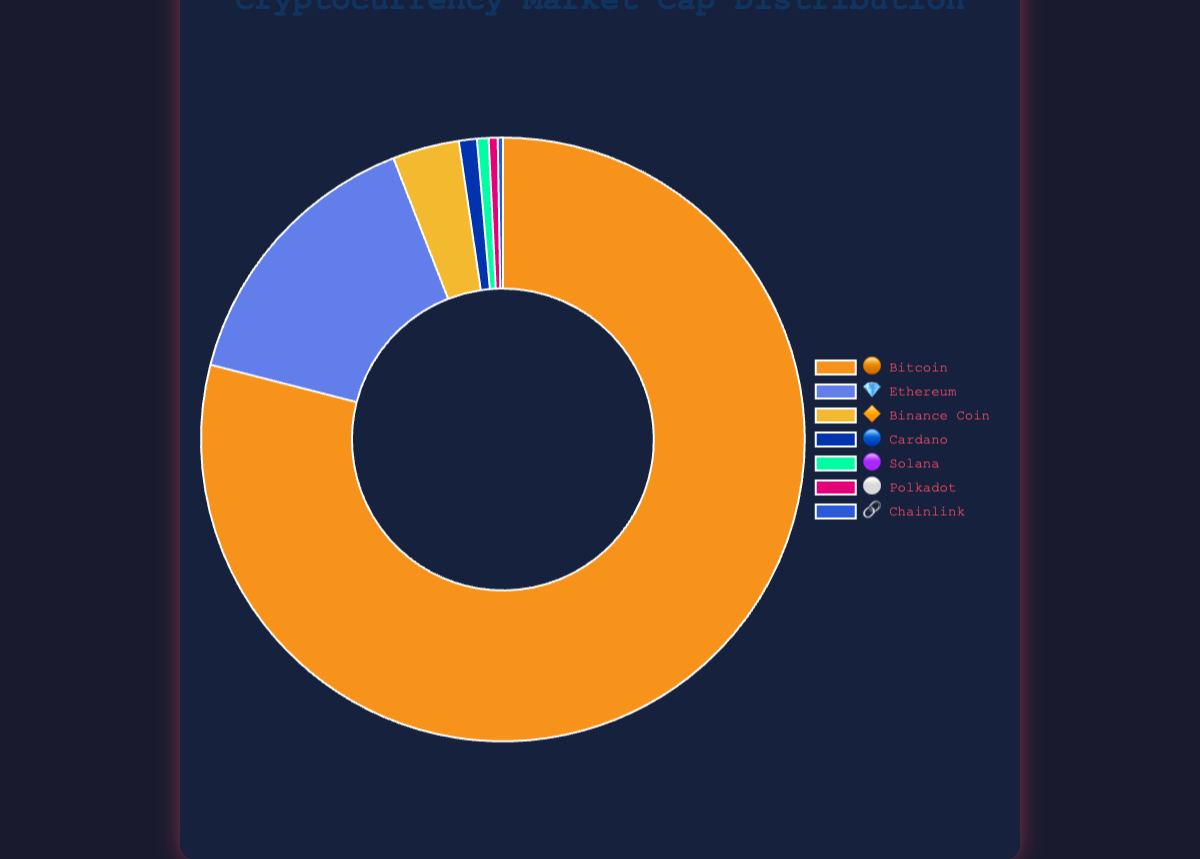What is the title of the chart? The title of the chart is placed at the top center in the container. The exact text shown there is "Cryptocurrency Market Cap Distribution".
Answer: Cryptocurrency Market Cap Distribution Which cryptocurrency has the highest market capitalization? 🟠 By looking at the size of the segments, the largest segment corresponds to Bitcoin, represented by the orange color and 🟠 emoji, meaning Bitcoin has the highest market capitalization.
Answer: Bitcoin How many cryptocurrencies are displayed in the chart? Counting the number of different emojis shown in the legend and segments of the doughnut chart, there are a total of 7 different cryptocurrencies.
Answer: 7 Which cryptocurrencies have market caps less than 10 billion USD? Observing the smaller segments in the chart and reading the tooltip values on hover, you can identify the cryptocurrencies. The chart shows that Solana 🟣 (9 billion), Polkadot ⚪ (7 billion), and Chainlink 🔗 (4 billion) all have market caps less than 10 billion USD.
Answer: Solana, Polkadot, Chainlink What is the combined market capitalization of Ethereum 💎 and Binance Coin 🔶? Looking at the chart, the market capitalization of Ethereum is 220 billion USD and that of Binance Coin is 52 billion USD. Summing these two gives 220 + 52 = 272 billion USD.
Answer: 272 billion USD Which cryptocurrency has a market capitalization closest to 50 billion USD? 🔶 By referring to the size of the segments and the tooltips, the Binance Coin 🔶 has a market capitalization of 52 billion USD, which is closest to 50 billion USD among all the displayed cryptocurrencies.
Answer: Binance Coin What proportion of the total market cap does Bitcoin 🟠 represent? The total market capitalization across all cryptocurrencies is approximately 1,219 billion USD (calculated as 1,150 + 220 + 52 + 14 + 9 + 7 + 4 billion). The proportion of Bitcoin is calculated as (1,150 / 1,456) * 100%.
Answer: Approximately 94.3% How does the market cap of Polkadot ⚪ compare to that of Solana 🟣? The market cap of Polkadot is 7 billion USD while that of Solana is 9 billion USD. Thus, Polkadot’s market cap is 2 billion USD less than Solana’s.
Answer: 2 billion USD less 